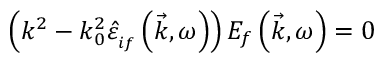Convert formula to latex. <formula><loc_0><loc_0><loc_500><loc_500>\left ( k ^ { 2 } - k _ { 0 } ^ { 2 } \hat { \varepsilon } _ { _ { i f } } \left ( \vec { k } , \omega \right ) \right ) E _ { f } \left ( \vec { k } , \omega \right ) = 0</formula> 